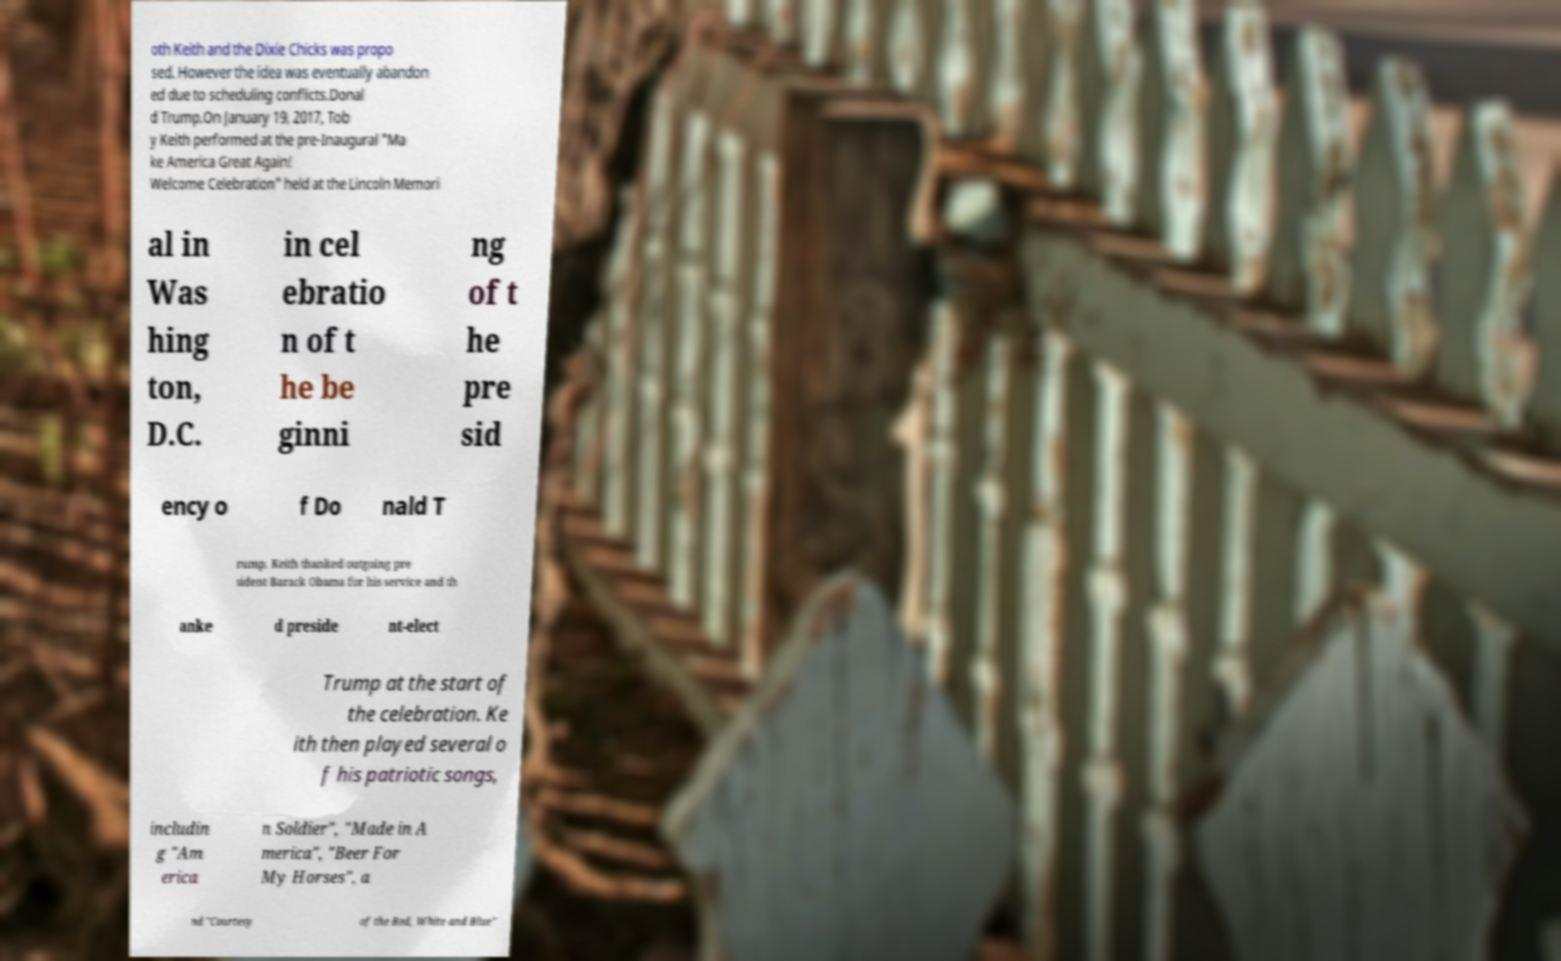Please read and relay the text visible in this image. What does it say? oth Keith and the Dixie Chicks was propo sed. However the idea was eventually abandon ed due to scheduling conflicts.Donal d Trump.On January 19, 2017, Tob y Keith performed at the pre-Inaugural "Ma ke America Great Again! Welcome Celebration" held at the Lincoln Memori al in Was hing ton, D.C. in cel ebratio n of t he be ginni ng of t he pre sid ency o f Do nald T rump. Keith thanked outgoing pre sident Barack Obama for his service and th anke d preside nt-elect Trump at the start of the celebration. Ke ith then played several o f his patriotic songs, includin g "Am erica n Soldier", "Made in A merica", "Beer For My Horses", a nd "Courtesy of the Red, White and Blue" 